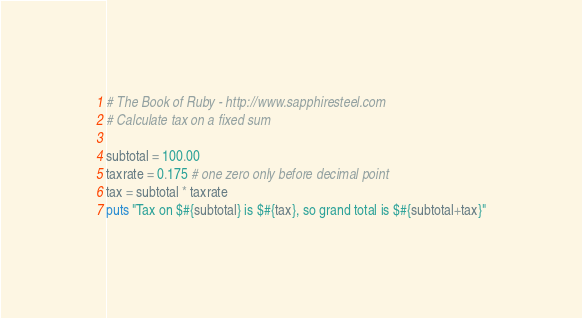Convert code to text. <code><loc_0><loc_0><loc_500><loc_500><_Ruby_># The Book of Ruby - http://www.sapphiresteel.com
# Calculate tax on a fixed sum

subtotal = 100.00
taxrate = 0.175 # one zero only before decimal point
tax = subtotal * taxrate
puts "Tax on $#{subtotal} is $#{tax}, so grand total is $#{subtotal+tax}"</code> 